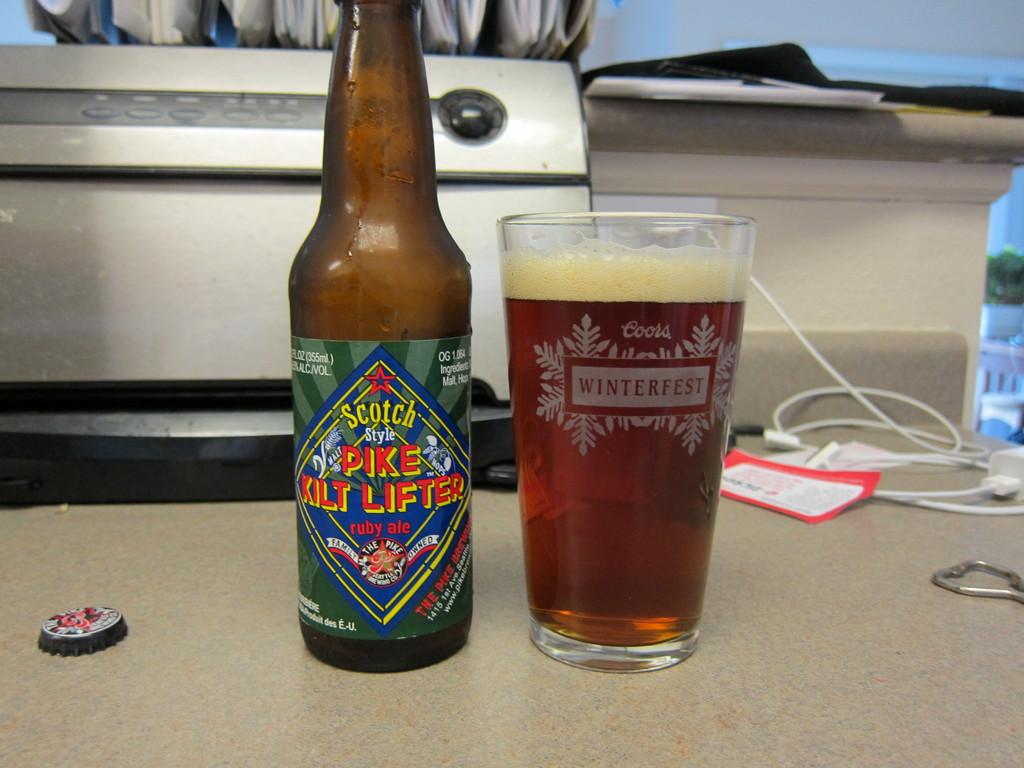What beer brand is on the glass?
Ensure brevity in your answer.  Coors. What kind of beer is this?
Offer a very short reply. Ruby ale. 